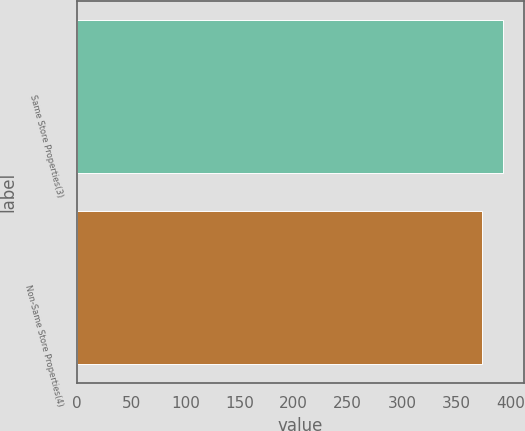Convert chart to OTSL. <chart><loc_0><loc_0><loc_500><loc_500><bar_chart><fcel>Same Store Properties(3)<fcel>Non-Same Store Properties(4)<nl><fcel>393<fcel>374<nl></chart> 